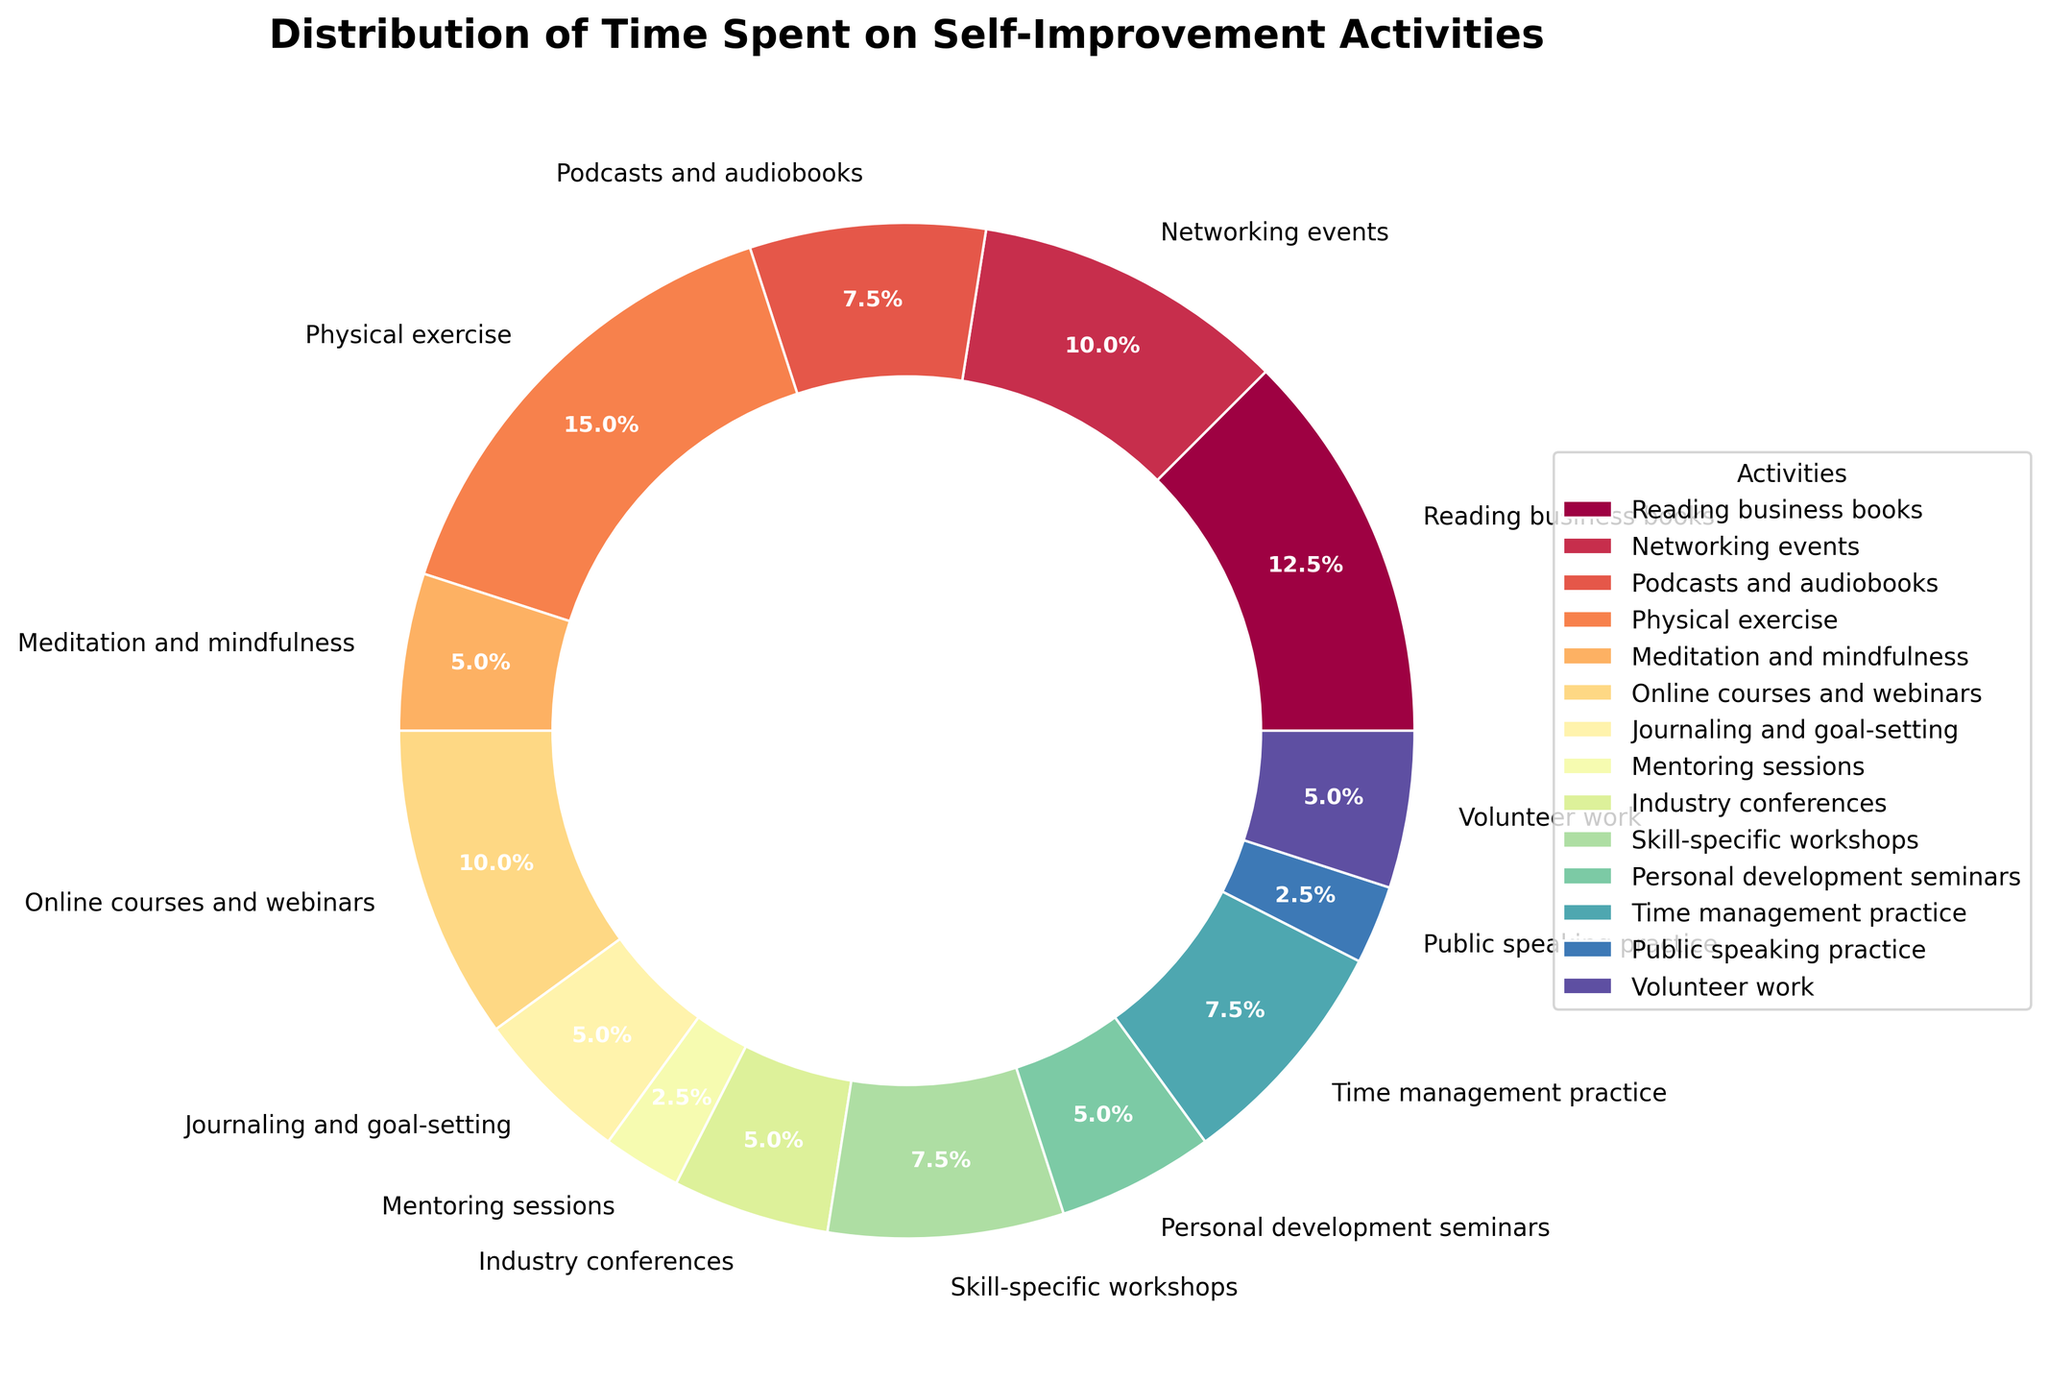What activity consumes the most time per week? To find the activity that consumes the most time, look for the largest wedge in the pie chart. That wedge corresponds to 'Physical exercise,' which takes up the biggest portion.
Answer: Physical exercise How many hours per week are spent on reading business books and online courses combined? Identify the hours for 'Reading business books' (5 hours) and 'Online courses and webinars' (4 hours). Add these values together to get the total.
Answer: 9 hours Which activity consumes more time: networking events or skill-specific workshops? Compare the wedges representing 'Networking events' and 'Skill-specific workshops.' 'Networking events' has 4 hours, while 'Skill-specific workshops' has 3 hours.
Answer: Networking events What is the percentage of time spent on meditation and mindfulness? Locate the wedge for 'Meditation and mindfulness' and check its percentage label, which is 2 hours out of the total. In the chart, it shows the percentage as 7.7%.
Answer: 7.7% What's the combined time spent on mentoring sessions, public speaking practice, and volunteer work? Add the hours for 'Mentoring sessions' (1 hour), 'Public speaking practice' (1 hour), and 'Volunteer work' (2 hours). The total is 1 + 1 + 2 = 4 hours.
Answer: 4 hours Which activity has the least amount of time dedicated to it, and how many hours is it? Find the smallest wedge on the pie chart. 'Public speaking practice' and 'Mentoring sessions' both have the smallest wedges, each representing 1 hour.
Answer: Public speaking practice and Mentoring sessions, 1 hour Are more hours spent on time management practice or industry conferences? Compare the wedges representing 'Time management practice' and 'Industry conferences.' 'Time management practice' has 3 hours, and 'Industry conferences' has 2 hours.
Answer: Time management practice How many activities consume less than 3 hours per week? Count the wedges that correspond to activities with less than 3 hours. These include 'Meditation and mindfulness' (2 hours), 'Journaling and goal-setting' (2 hours), 'Mentoring sessions' (1 hour), 'Industry conferences' (2 hours), 'Public speaking practice' (1 hour), and 'Volunteer work' (2 hours). So, there are 6 activities.
Answer: 6 activities What is the difference in time spent between physical exercise and reading business books? Identify the hours for 'Physical exercise' (6 hours) and 'Reading business books' (5 hours). Subtract the smaller value from the larger one: 6 - 5 = 1 hour.
Answer: 1 hour 